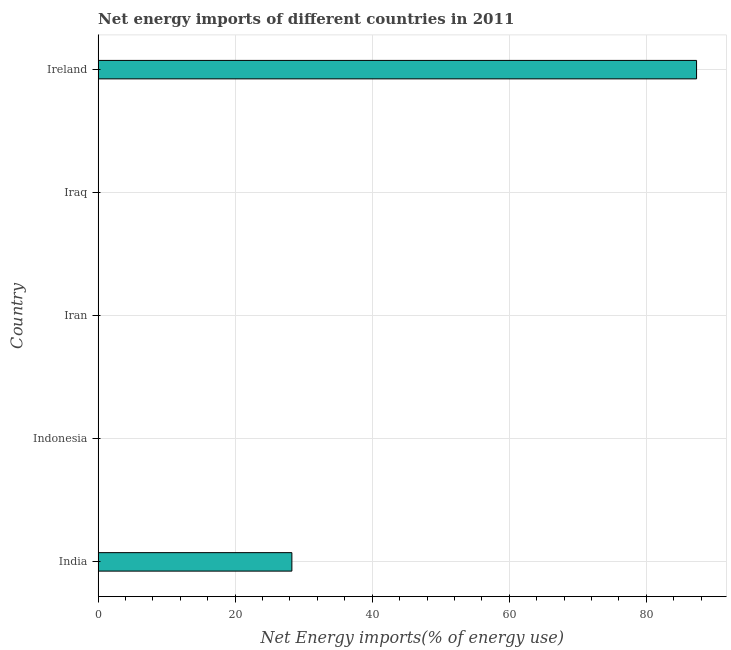Does the graph contain grids?
Your answer should be very brief. Yes. What is the title of the graph?
Offer a very short reply. Net energy imports of different countries in 2011. What is the label or title of the X-axis?
Make the answer very short. Net Energy imports(% of energy use). What is the label or title of the Y-axis?
Give a very brief answer. Country. What is the energy imports in Ireland?
Give a very brief answer. 87.34. Across all countries, what is the maximum energy imports?
Make the answer very short. 87.34. Across all countries, what is the minimum energy imports?
Your response must be concise. 0. In which country was the energy imports maximum?
Your answer should be compact. Ireland. What is the sum of the energy imports?
Give a very brief answer. 115.62. What is the average energy imports per country?
Keep it short and to the point. 23.12. In how many countries, is the energy imports greater than 76 %?
Offer a terse response. 1. What is the difference between the highest and the lowest energy imports?
Offer a very short reply. 87.34. In how many countries, is the energy imports greater than the average energy imports taken over all countries?
Your answer should be compact. 2. How many bars are there?
Your answer should be compact. 2. Are all the bars in the graph horizontal?
Your answer should be very brief. Yes. How many countries are there in the graph?
Provide a succinct answer. 5. What is the difference between two consecutive major ticks on the X-axis?
Provide a short and direct response. 20. Are the values on the major ticks of X-axis written in scientific E-notation?
Keep it short and to the point. No. What is the Net Energy imports(% of energy use) of India?
Your answer should be compact. 28.28. What is the Net Energy imports(% of energy use) of Indonesia?
Your answer should be compact. 0. What is the Net Energy imports(% of energy use) in Iran?
Ensure brevity in your answer.  0. What is the Net Energy imports(% of energy use) in Iraq?
Give a very brief answer. 0. What is the Net Energy imports(% of energy use) in Ireland?
Your answer should be very brief. 87.34. What is the difference between the Net Energy imports(% of energy use) in India and Ireland?
Provide a succinct answer. -59.07. What is the ratio of the Net Energy imports(% of energy use) in India to that in Ireland?
Your answer should be very brief. 0.32. 